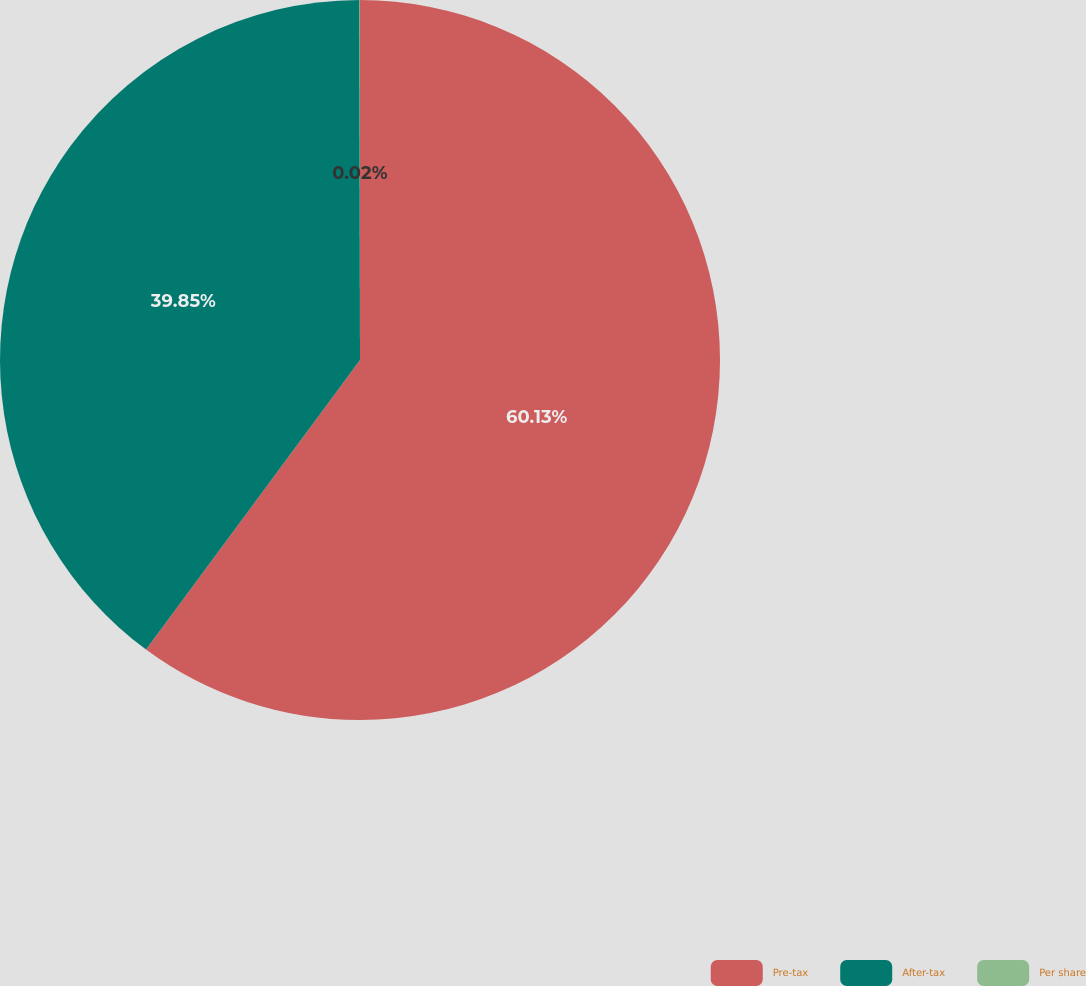<chart> <loc_0><loc_0><loc_500><loc_500><pie_chart><fcel>Pre-tax<fcel>After-tax<fcel>Per share<nl><fcel>60.13%<fcel>39.85%<fcel>0.02%<nl></chart> 